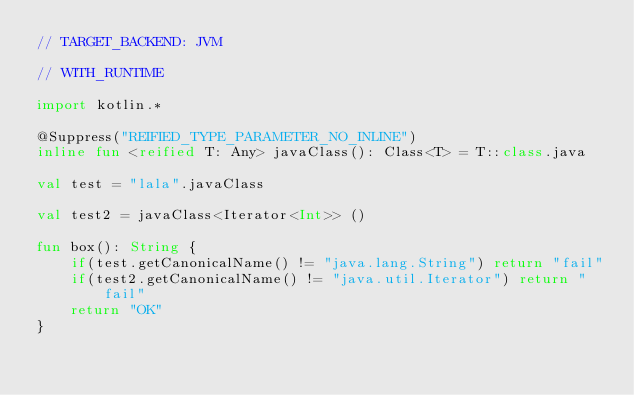Convert code to text. <code><loc_0><loc_0><loc_500><loc_500><_Kotlin_>// TARGET_BACKEND: JVM

// WITH_RUNTIME

import kotlin.*

@Suppress("REIFIED_TYPE_PARAMETER_NO_INLINE")
inline fun <reified T: Any> javaClass(): Class<T> = T::class.java

val test = "lala".javaClass

val test2 = javaClass<Iterator<Int>> ()

fun box(): String {
    if(test.getCanonicalName() != "java.lang.String") return "fail"
    if(test2.getCanonicalName() != "java.util.Iterator") return "fail"
    return "OK"
}
</code> 